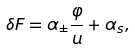<formula> <loc_0><loc_0><loc_500><loc_500>\delta F = \alpha _ { \pm } \frac { \varphi } { u } + \alpha _ { s } ,</formula> 